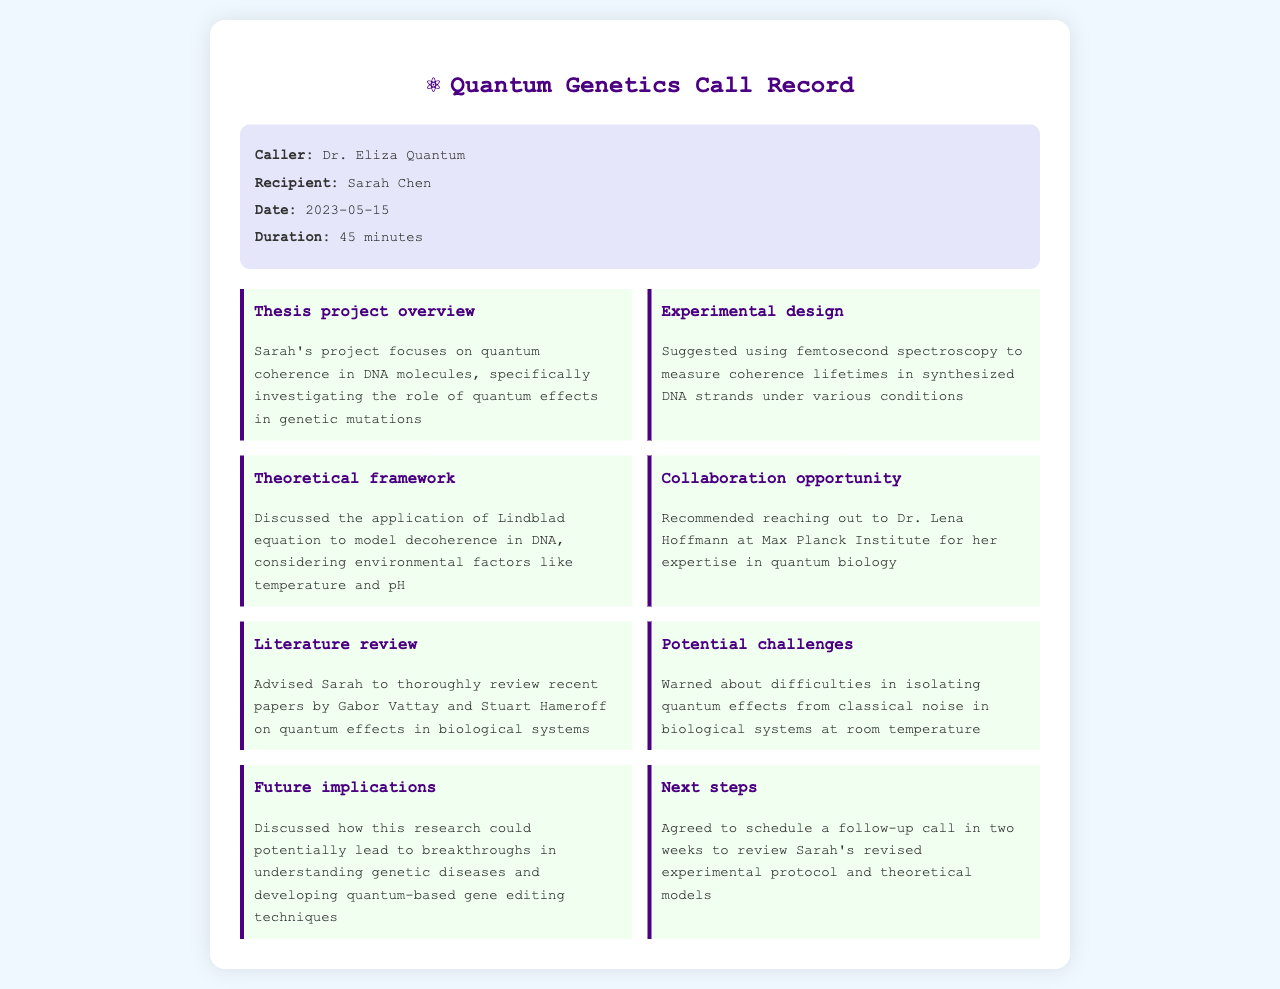What is the name of the caller? The caller is identified at the beginning of the document as Dr. Eliza Quantum.
Answer: Dr. Eliza Quantum Who is the recipient of the call? The recipient, mentioned in the header of the document, is Sarah Chen.
Answer: Sarah Chen What is the duration of the call? The duration is noted in the call details section as 45 minutes.
Answer: 45 minutes What is the main focus of Sarah's thesis project? The document states that Sarah's project focuses on quantum coherence in DNA molecules.
Answer: quantum coherence in DNA molecules Which spectroscopy method was suggested for the experimental design? The document mentions that femtosecond spectroscopy was suggested for measuring coherence lifetimes.
Answer: femtosecond spectroscopy What equation was discussed to model decoherence in DNA? The conversation points out the Lindblad equation as the model for decoherence in DNA.
Answer: Lindblad equation Who was recommended for collaboration? The document mentions contacting Dr. Lena Hoffmann at the Max Planck Institute.
Answer: Dr. Lena Hoffmann What publication authors were advised for the literature review? The advised authors for reviewing recent papers are Gabor Vattay and Stuart Hameroff.
Answer: Gabor Vattay and Stuart Hameroff What is a potential challenge mentioned in isolating quantum effects? The call warns about difficulties in isolating quantum effects from classical noise in biological systems at room temperature.
Answer: isolating quantum effects from classical noise What are the next steps agreed upon during the call? The next steps include scheduling a follow-up call in two weeks to review Sarah's revised experimental protocol.
Answer: schedule a follow-up call in two weeks 